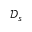<formula> <loc_0><loc_0><loc_500><loc_500>\mathcal { D } _ { s }</formula> 